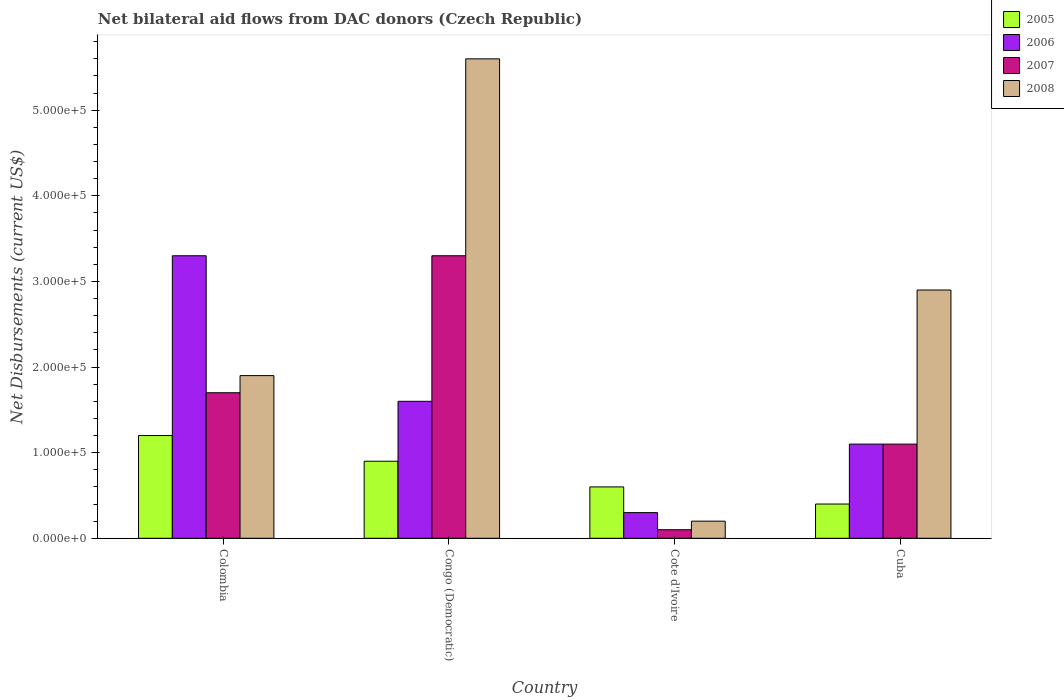How many different coloured bars are there?
Give a very brief answer. 4. How many bars are there on the 4th tick from the right?
Provide a succinct answer. 4. What is the net bilateral aid flows in 2008 in Congo (Democratic)?
Offer a very short reply. 5.60e+05. Across all countries, what is the maximum net bilateral aid flows in 2008?
Offer a very short reply. 5.60e+05. Across all countries, what is the minimum net bilateral aid flows in 2008?
Your response must be concise. 2.00e+04. In which country was the net bilateral aid flows in 2007 maximum?
Ensure brevity in your answer.  Congo (Democratic). In which country was the net bilateral aid flows in 2008 minimum?
Make the answer very short. Cote d'Ivoire. What is the average net bilateral aid flows in 2007 per country?
Your answer should be compact. 1.55e+05. What is the ratio of the net bilateral aid flows in 2007 in Cote d'Ivoire to that in Cuba?
Your answer should be compact. 0.09. What is the difference between the highest and the second highest net bilateral aid flows in 2005?
Offer a very short reply. 6.00e+04. Is the sum of the net bilateral aid flows in 2008 in Colombia and Congo (Democratic) greater than the maximum net bilateral aid flows in 2005 across all countries?
Give a very brief answer. Yes. Is it the case that in every country, the sum of the net bilateral aid flows in 2008 and net bilateral aid flows in 2006 is greater than the sum of net bilateral aid flows in 2005 and net bilateral aid flows in 2007?
Ensure brevity in your answer.  No. What does the 3rd bar from the left in Colombia represents?
Give a very brief answer. 2007. Is it the case that in every country, the sum of the net bilateral aid flows in 2005 and net bilateral aid flows in 2007 is greater than the net bilateral aid flows in 2008?
Your answer should be very brief. No. What is the difference between two consecutive major ticks on the Y-axis?
Make the answer very short. 1.00e+05. How many legend labels are there?
Provide a short and direct response. 4. How are the legend labels stacked?
Your response must be concise. Vertical. What is the title of the graph?
Your response must be concise. Net bilateral aid flows from DAC donors (Czech Republic). What is the label or title of the X-axis?
Provide a succinct answer. Country. What is the label or title of the Y-axis?
Offer a very short reply. Net Disbursements (current US$). What is the Net Disbursements (current US$) of 2008 in Colombia?
Your answer should be compact. 1.90e+05. What is the Net Disbursements (current US$) of 2005 in Congo (Democratic)?
Offer a terse response. 9.00e+04. What is the Net Disbursements (current US$) of 2006 in Congo (Democratic)?
Keep it short and to the point. 1.60e+05. What is the Net Disbursements (current US$) in 2007 in Congo (Democratic)?
Make the answer very short. 3.30e+05. What is the Net Disbursements (current US$) of 2008 in Congo (Democratic)?
Offer a terse response. 5.60e+05. What is the Net Disbursements (current US$) in 2005 in Cote d'Ivoire?
Keep it short and to the point. 6.00e+04. What is the Net Disbursements (current US$) of 2006 in Cote d'Ivoire?
Your response must be concise. 3.00e+04. What is the Net Disbursements (current US$) in 2007 in Cote d'Ivoire?
Offer a terse response. 10000. What is the Net Disbursements (current US$) of 2007 in Cuba?
Keep it short and to the point. 1.10e+05. Across all countries, what is the maximum Net Disbursements (current US$) of 2005?
Provide a short and direct response. 1.20e+05. Across all countries, what is the maximum Net Disbursements (current US$) in 2007?
Make the answer very short. 3.30e+05. Across all countries, what is the maximum Net Disbursements (current US$) in 2008?
Your answer should be compact. 5.60e+05. Across all countries, what is the minimum Net Disbursements (current US$) in 2007?
Make the answer very short. 10000. Across all countries, what is the minimum Net Disbursements (current US$) of 2008?
Make the answer very short. 2.00e+04. What is the total Net Disbursements (current US$) of 2006 in the graph?
Your answer should be compact. 6.30e+05. What is the total Net Disbursements (current US$) of 2007 in the graph?
Offer a terse response. 6.20e+05. What is the total Net Disbursements (current US$) of 2008 in the graph?
Provide a short and direct response. 1.06e+06. What is the difference between the Net Disbursements (current US$) of 2007 in Colombia and that in Congo (Democratic)?
Offer a terse response. -1.60e+05. What is the difference between the Net Disbursements (current US$) in 2008 in Colombia and that in Congo (Democratic)?
Your answer should be very brief. -3.70e+05. What is the difference between the Net Disbursements (current US$) in 2005 in Colombia and that in Cote d'Ivoire?
Your response must be concise. 6.00e+04. What is the difference between the Net Disbursements (current US$) in 2007 in Colombia and that in Cote d'Ivoire?
Ensure brevity in your answer.  1.60e+05. What is the difference between the Net Disbursements (current US$) of 2008 in Colombia and that in Cote d'Ivoire?
Your answer should be compact. 1.70e+05. What is the difference between the Net Disbursements (current US$) of 2005 in Colombia and that in Cuba?
Provide a short and direct response. 8.00e+04. What is the difference between the Net Disbursements (current US$) in 2007 in Colombia and that in Cuba?
Your response must be concise. 6.00e+04. What is the difference between the Net Disbursements (current US$) in 2005 in Congo (Democratic) and that in Cote d'Ivoire?
Make the answer very short. 3.00e+04. What is the difference between the Net Disbursements (current US$) of 2008 in Congo (Democratic) and that in Cote d'Ivoire?
Keep it short and to the point. 5.40e+05. What is the difference between the Net Disbursements (current US$) in 2005 in Congo (Democratic) and that in Cuba?
Provide a succinct answer. 5.00e+04. What is the difference between the Net Disbursements (current US$) of 2006 in Congo (Democratic) and that in Cuba?
Your response must be concise. 5.00e+04. What is the difference between the Net Disbursements (current US$) of 2007 in Congo (Democratic) and that in Cuba?
Keep it short and to the point. 2.20e+05. What is the difference between the Net Disbursements (current US$) in 2008 in Congo (Democratic) and that in Cuba?
Make the answer very short. 2.70e+05. What is the difference between the Net Disbursements (current US$) of 2006 in Cote d'Ivoire and that in Cuba?
Offer a very short reply. -8.00e+04. What is the difference between the Net Disbursements (current US$) in 2008 in Cote d'Ivoire and that in Cuba?
Make the answer very short. -2.70e+05. What is the difference between the Net Disbursements (current US$) of 2005 in Colombia and the Net Disbursements (current US$) of 2006 in Congo (Democratic)?
Ensure brevity in your answer.  -4.00e+04. What is the difference between the Net Disbursements (current US$) of 2005 in Colombia and the Net Disbursements (current US$) of 2007 in Congo (Democratic)?
Make the answer very short. -2.10e+05. What is the difference between the Net Disbursements (current US$) in 2005 in Colombia and the Net Disbursements (current US$) in 2008 in Congo (Democratic)?
Your answer should be very brief. -4.40e+05. What is the difference between the Net Disbursements (current US$) of 2006 in Colombia and the Net Disbursements (current US$) of 2008 in Congo (Democratic)?
Your response must be concise. -2.30e+05. What is the difference between the Net Disbursements (current US$) of 2007 in Colombia and the Net Disbursements (current US$) of 2008 in Congo (Democratic)?
Ensure brevity in your answer.  -3.90e+05. What is the difference between the Net Disbursements (current US$) in 2005 in Colombia and the Net Disbursements (current US$) in 2007 in Cote d'Ivoire?
Give a very brief answer. 1.10e+05. What is the difference between the Net Disbursements (current US$) of 2005 in Colombia and the Net Disbursements (current US$) of 2008 in Cote d'Ivoire?
Provide a short and direct response. 1.00e+05. What is the difference between the Net Disbursements (current US$) of 2006 in Colombia and the Net Disbursements (current US$) of 2008 in Cote d'Ivoire?
Provide a succinct answer. 3.10e+05. What is the difference between the Net Disbursements (current US$) of 2005 in Colombia and the Net Disbursements (current US$) of 2006 in Cuba?
Keep it short and to the point. 10000. What is the difference between the Net Disbursements (current US$) in 2005 in Colombia and the Net Disbursements (current US$) in 2007 in Cuba?
Your answer should be compact. 10000. What is the difference between the Net Disbursements (current US$) in 2005 in Colombia and the Net Disbursements (current US$) in 2008 in Cuba?
Your answer should be very brief. -1.70e+05. What is the difference between the Net Disbursements (current US$) of 2006 in Colombia and the Net Disbursements (current US$) of 2008 in Cuba?
Offer a terse response. 4.00e+04. What is the difference between the Net Disbursements (current US$) in 2007 in Colombia and the Net Disbursements (current US$) in 2008 in Cuba?
Ensure brevity in your answer.  -1.20e+05. What is the difference between the Net Disbursements (current US$) in 2005 in Congo (Democratic) and the Net Disbursements (current US$) in 2008 in Cote d'Ivoire?
Provide a short and direct response. 7.00e+04. What is the difference between the Net Disbursements (current US$) in 2006 in Congo (Democratic) and the Net Disbursements (current US$) in 2007 in Cote d'Ivoire?
Ensure brevity in your answer.  1.50e+05. What is the difference between the Net Disbursements (current US$) in 2006 in Congo (Democratic) and the Net Disbursements (current US$) in 2008 in Cote d'Ivoire?
Make the answer very short. 1.40e+05. What is the difference between the Net Disbursements (current US$) of 2005 in Congo (Democratic) and the Net Disbursements (current US$) of 2008 in Cuba?
Provide a succinct answer. -2.00e+05. What is the difference between the Net Disbursements (current US$) of 2007 in Congo (Democratic) and the Net Disbursements (current US$) of 2008 in Cuba?
Your answer should be compact. 4.00e+04. What is the difference between the Net Disbursements (current US$) of 2005 in Cote d'Ivoire and the Net Disbursements (current US$) of 2008 in Cuba?
Provide a succinct answer. -2.30e+05. What is the difference between the Net Disbursements (current US$) of 2006 in Cote d'Ivoire and the Net Disbursements (current US$) of 2008 in Cuba?
Your answer should be very brief. -2.60e+05. What is the difference between the Net Disbursements (current US$) of 2007 in Cote d'Ivoire and the Net Disbursements (current US$) of 2008 in Cuba?
Keep it short and to the point. -2.80e+05. What is the average Net Disbursements (current US$) of 2005 per country?
Offer a terse response. 7.75e+04. What is the average Net Disbursements (current US$) of 2006 per country?
Provide a succinct answer. 1.58e+05. What is the average Net Disbursements (current US$) of 2007 per country?
Offer a terse response. 1.55e+05. What is the average Net Disbursements (current US$) in 2008 per country?
Your answer should be compact. 2.65e+05. What is the difference between the Net Disbursements (current US$) of 2005 and Net Disbursements (current US$) of 2007 in Colombia?
Make the answer very short. -5.00e+04. What is the difference between the Net Disbursements (current US$) of 2005 and Net Disbursements (current US$) of 2008 in Colombia?
Your response must be concise. -7.00e+04. What is the difference between the Net Disbursements (current US$) in 2006 and Net Disbursements (current US$) in 2007 in Colombia?
Offer a terse response. 1.60e+05. What is the difference between the Net Disbursements (current US$) of 2007 and Net Disbursements (current US$) of 2008 in Colombia?
Make the answer very short. -2.00e+04. What is the difference between the Net Disbursements (current US$) in 2005 and Net Disbursements (current US$) in 2006 in Congo (Democratic)?
Offer a terse response. -7.00e+04. What is the difference between the Net Disbursements (current US$) of 2005 and Net Disbursements (current US$) of 2007 in Congo (Democratic)?
Provide a short and direct response. -2.40e+05. What is the difference between the Net Disbursements (current US$) of 2005 and Net Disbursements (current US$) of 2008 in Congo (Democratic)?
Provide a short and direct response. -4.70e+05. What is the difference between the Net Disbursements (current US$) of 2006 and Net Disbursements (current US$) of 2008 in Congo (Democratic)?
Your answer should be very brief. -4.00e+05. What is the difference between the Net Disbursements (current US$) in 2007 and Net Disbursements (current US$) in 2008 in Congo (Democratic)?
Make the answer very short. -2.30e+05. What is the difference between the Net Disbursements (current US$) of 2005 and Net Disbursements (current US$) of 2006 in Cote d'Ivoire?
Your answer should be compact. 3.00e+04. What is the difference between the Net Disbursements (current US$) in 2005 and Net Disbursements (current US$) in 2008 in Cote d'Ivoire?
Keep it short and to the point. 4.00e+04. What is the difference between the Net Disbursements (current US$) in 2006 and Net Disbursements (current US$) in 2007 in Cote d'Ivoire?
Your answer should be very brief. 2.00e+04. What is the difference between the Net Disbursements (current US$) of 2007 and Net Disbursements (current US$) of 2008 in Cote d'Ivoire?
Offer a terse response. -10000. What is the difference between the Net Disbursements (current US$) in 2005 and Net Disbursements (current US$) in 2008 in Cuba?
Offer a terse response. -2.50e+05. What is the difference between the Net Disbursements (current US$) in 2007 and Net Disbursements (current US$) in 2008 in Cuba?
Offer a terse response. -1.80e+05. What is the ratio of the Net Disbursements (current US$) of 2006 in Colombia to that in Congo (Democratic)?
Offer a very short reply. 2.06. What is the ratio of the Net Disbursements (current US$) in 2007 in Colombia to that in Congo (Democratic)?
Ensure brevity in your answer.  0.52. What is the ratio of the Net Disbursements (current US$) in 2008 in Colombia to that in Congo (Democratic)?
Provide a short and direct response. 0.34. What is the ratio of the Net Disbursements (current US$) of 2006 in Colombia to that in Cote d'Ivoire?
Ensure brevity in your answer.  11. What is the ratio of the Net Disbursements (current US$) in 2007 in Colombia to that in Cuba?
Ensure brevity in your answer.  1.55. What is the ratio of the Net Disbursements (current US$) of 2008 in Colombia to that in Cuba?
Give a very brief answer. 0.66. What is the ratio of the Net Disbursements (current US$) in 2006 in Congo (Democratic) to that in Cote d'Ivoire?
Ensure brevity in your answer.  5.33. What is the ratio of the Net Disbursements (current US$) of 2007 in Congo (Democratic) to that in Cote d'Ivoire?
Ensure brevity in your answer.  33. What is the ratio of the Net Disbursements (current US$) in 2005 in Congo (Democratic) to that in Cuba?
Offer a very short reply. 2.25. What is the ratio of the Net Disbursements (current US$) of 2006 in Congo (Democratic) to that in Cuba?
Make the answer very short. 1.45. What is the ratio of the Net Disbursements (current US$) in 2008 in Congo (Democratic) to that in Cuba?
Ensure brevity in your answer.  1.93. What is the ratio of the Net Disbursements (current US$) of 2005 in Cote d'Ivoire to that in Cuba?
Offer a very short reply. 1.5. What is the ratio of the Net Disbursements (current US$) of 2006 in Cote d'Ivoire to that in Cuba?
Offer a very short reply. 0.27. What is the ratio of the Net Disbursements (current US$) of 2007 in Cote d'Ivoire to that in Cuba?
Make the answer very short. 0.09. What is the ratio of the Net Disbursements (current US$) in 2008 in Cote d'Ivoire to that in Cuba?
Your answer should be very brief. 0.07. What is the difference between the highest and the second highest Net Disbursements (current US$) of 2005?
Your response must be concise. 3.00e+04. What is the difference between the highest and the second highest Net Disbursements (current US$) of 2006?
Offer a terse response. 1.70e+05. What is the difference between the highest and the lowest Net Disbursements (current US$) of 2005?
Make the answer very short. 8.00e+04. What is the difference between the highest and the lowest Net Disbursements (current US$) in 2008?
Offer a terse response. 5.40e+05. 